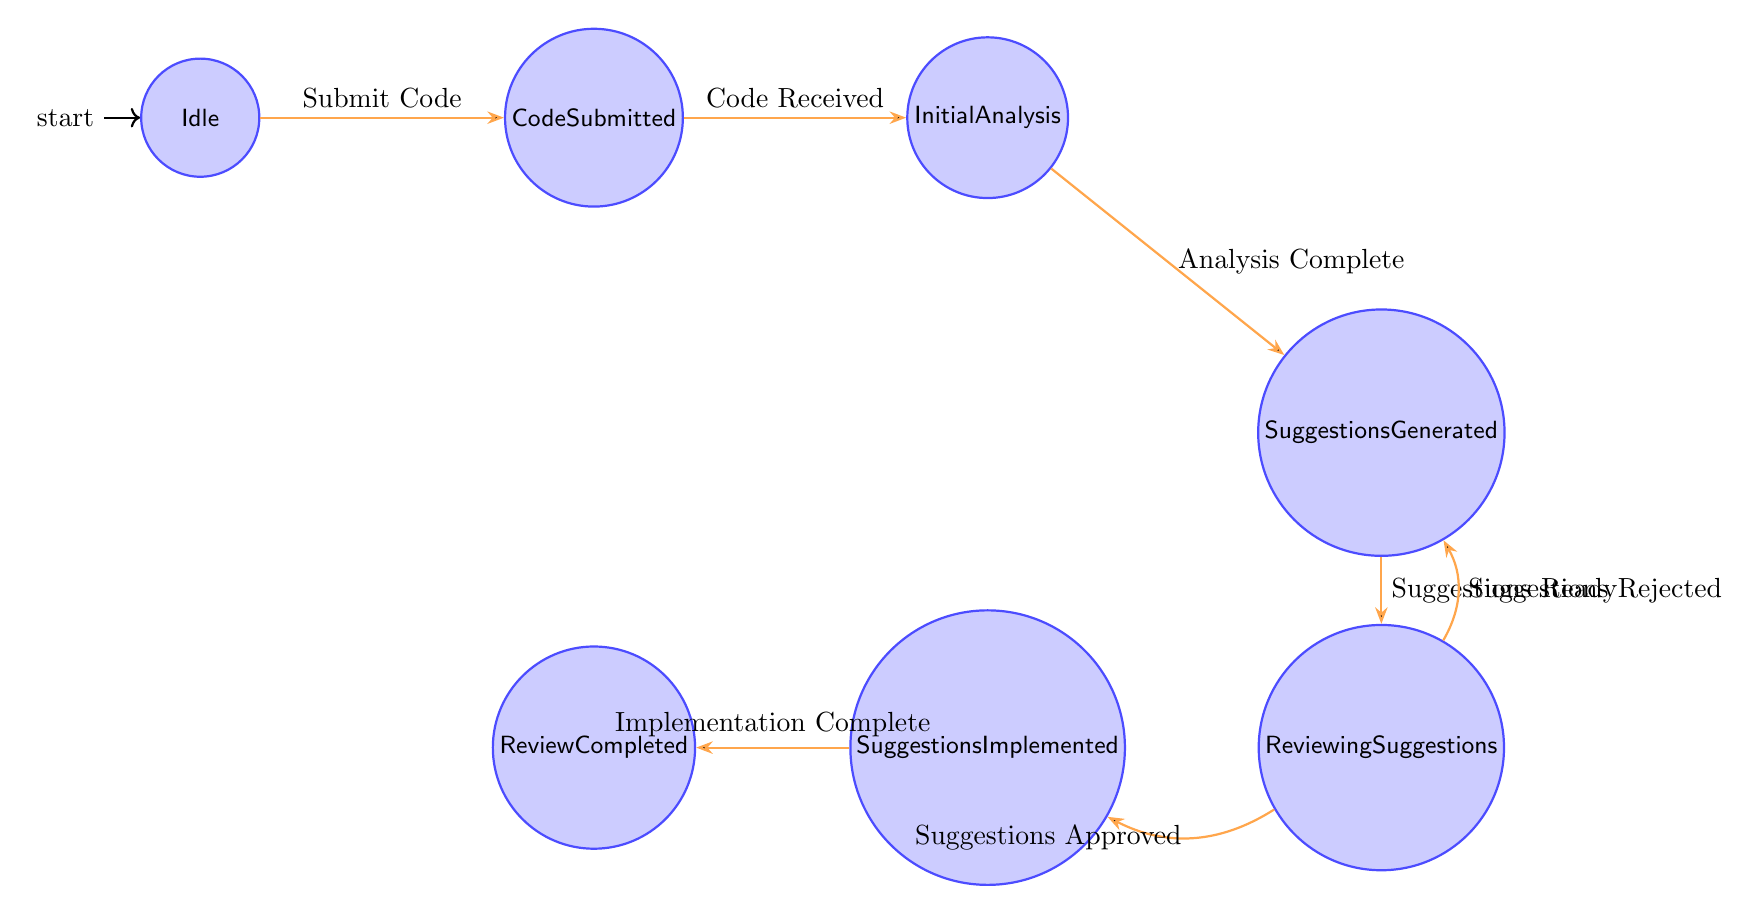What is the initial state of the system? The diagram indicates the initial state is labeled as "Idle." This is the first node in the finite state machine, showing where the process starts.
Answer: Idle How many states are represented in the diagram? There are seven distinct states depicted in the diagram. Counting each labeled node confirms this total.
Answer: 7 What is the action associated with the transition from "Code Submitted" to "Initial Analysis"? The transition action from "Code Submitted" to "Initial Analysis" is specified as "Begin initial analysis of code." This is indicated on the arrow connecting these two states.
Answer: Begin initial analysis of code What happens after suggestions are generated? After "Suggestions Generated," the next state is "Reviewing Suggestions," according to the transition labeled "Suggestions Ready." This indicates the flow of the process after this action.
Answer: Reviewing Suggestions If suggestions are rejected, which state is the process directed to? Upon rejection of suggestions, the process flows back to the "Suggestions Generated" state, as shown by the transition labeled "Suggestions Rejected." This indicates a revision of the suggestions is needed.
Answer: Suggestions Generated In which state does the code review process end? The final state of the process, indicated as the endpoint of the flow, is "Review Completed." This is the last node reached after all prior steps are fulfilled.
Answer: Review Completed What is the trigger for the transition from "Reviewing Suggestions" to "Suggestions Implemented"? The trigger for moving from "Reviewing Suggestions" to "Suggestions Implemented" is specified as "Suggestions Approved." This detail can be found in the labeled transition arrow connecting these two states.
Answer: Suggestions Approved How does a developer initiate the review process? A developer initiates the review process by performing the action labeled "Submit Code," leading from the "Idle" state to the "Code Submitted" state. This transition marks the start of the review cycle.
Answer: Submit Code 